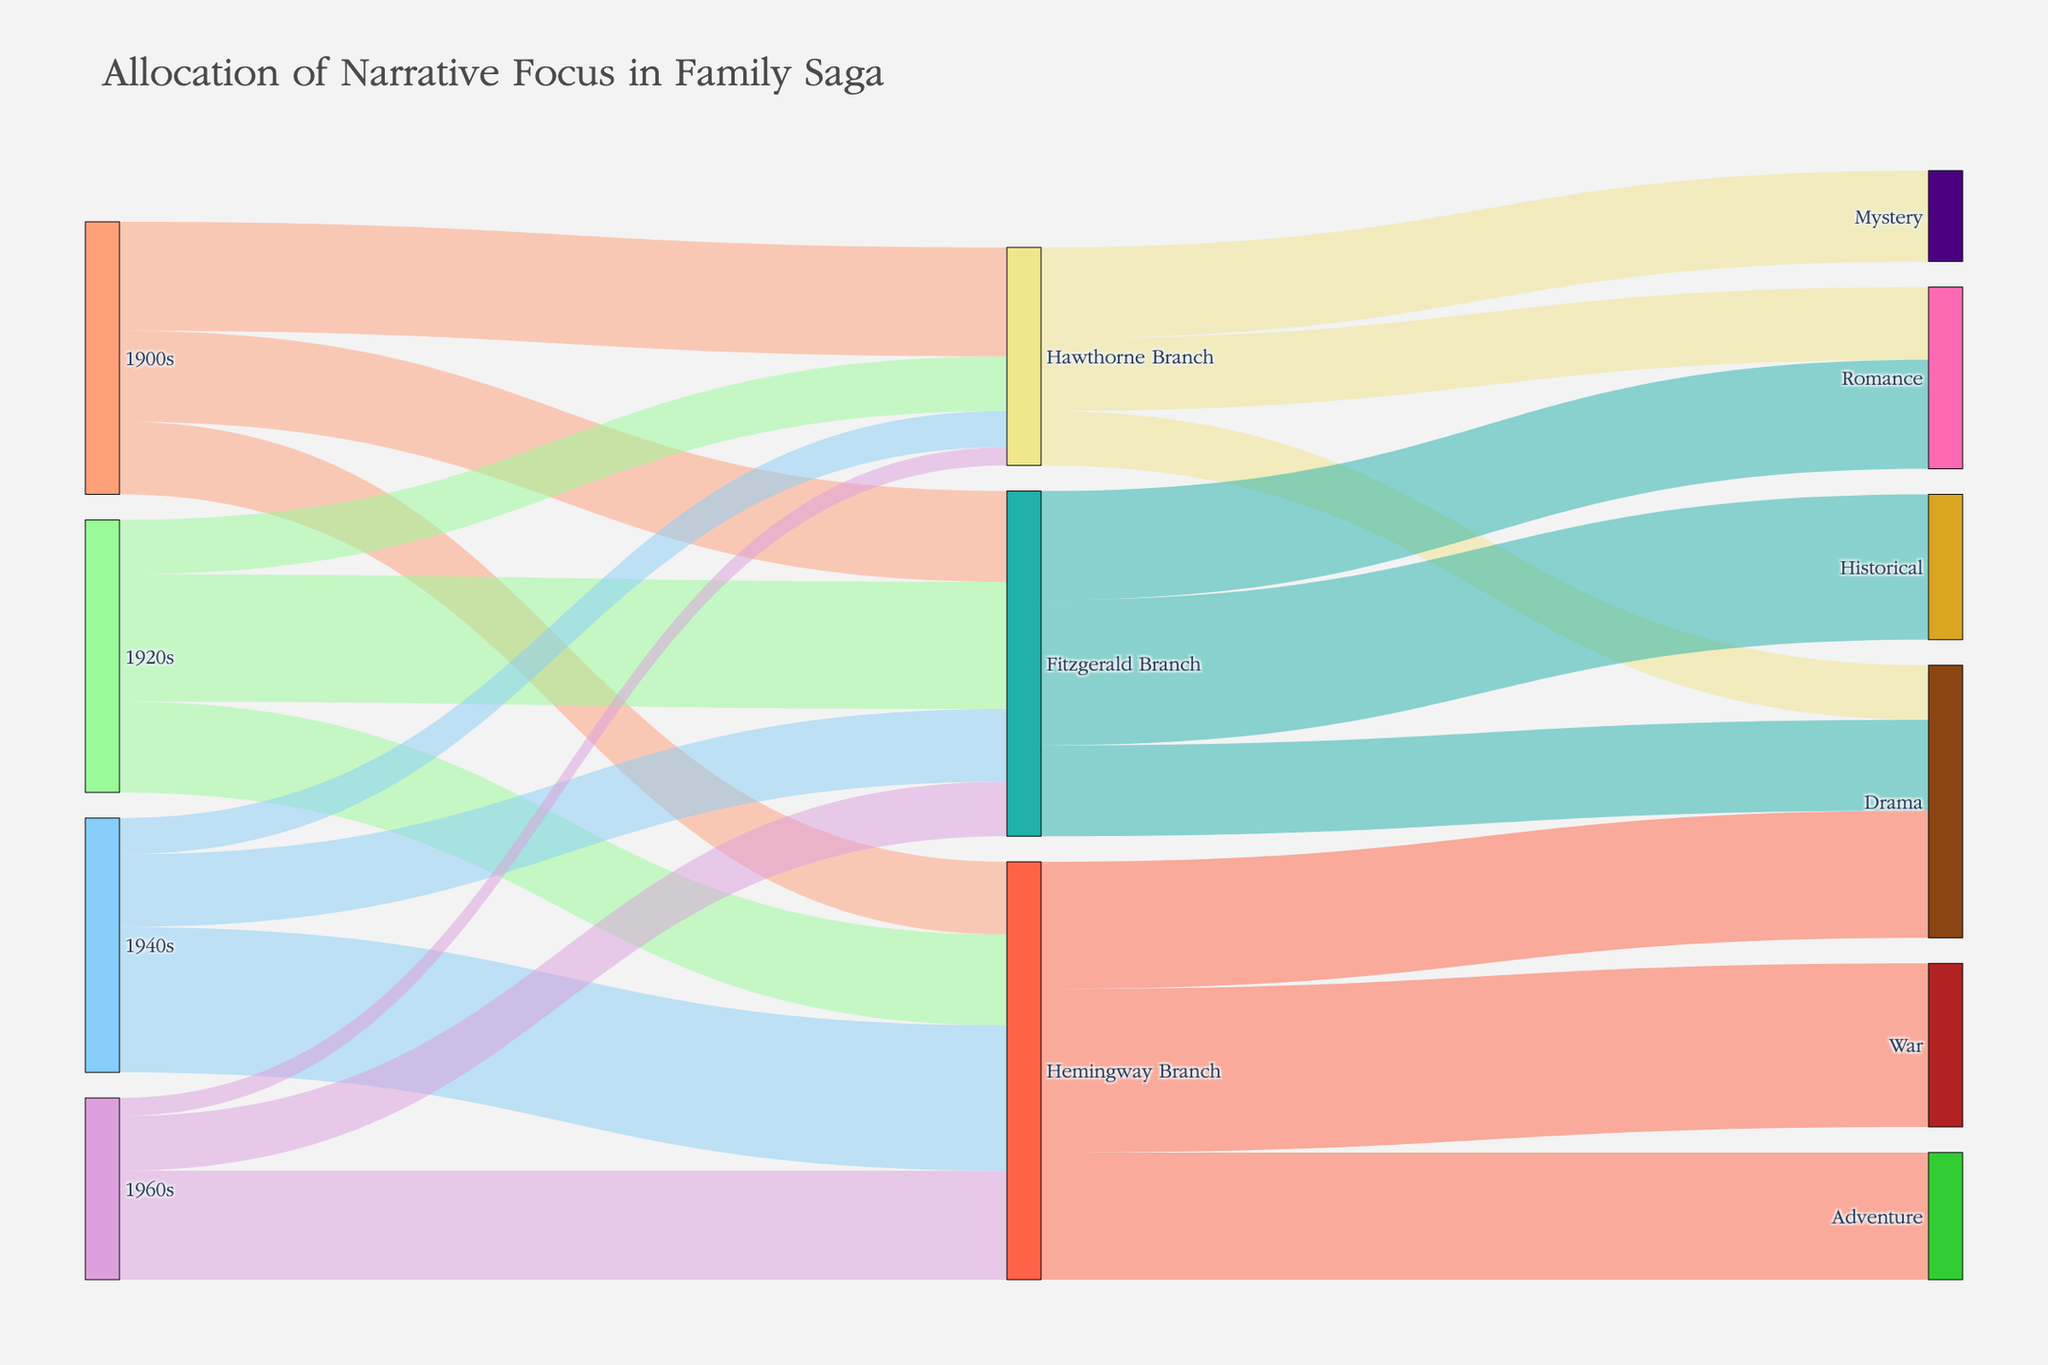Who has the most narrative focus in the 1960s? Look at the nodes connected to the "1960s" source; the "Hemingway Branch" has the largest value of 30, which is the highest among the branches from the 1960s.
Answer: Hemingway Branch Which family branch has the greatest narrative focus in the Romance genre? The branches leading to "Romance" should be considered. The "Fitzgerald Branch" with a value of 30 has the highest narrative focus in Romance.
Answer: Fitzgerald Branch What is the combined narrative focus of the "Hawthorne Branch" across all time periods? Add the values connecting from time periods to the "Hawthorne Branch": 30 (1900s) + 15 (1920s) + 10 (1940s) + 5 (1960s) = 60.
Answer: 60 Compare the narrative focus of "Adventure" and "Historical" genres. Which one has more focus? Look at the values of "Adventure" (35 from Hemingway) and "Historical" (40 from Fitzgerald). The "Historical" genre has a higher value.
Answer: Historical What is the total narrative focus on the "Drama" genre? Sum the narrative focuses: 15 (Hawthorne) + 25 (Fitzgerald) + 35 (Hemingway) = 75.
Answer: 75 What are the distinct time periods featured in the diagram? Identify the unique "source" nodes that are time periods: "1900s", "1920s", "1940s", "1960s".
Answer: 1900s, 1920s, 1940s, 1960s Which decade shows the highest combined narrative focus, and what is its value? Add the values for each decade: 1900s (75), 1920s (75), 1940s (70), and 1960s (50). The 1900s and 1920s both have the highest combined narrative focus of 75.
Answer: 1900s, 1920s, 75 What proportion of the Fitzgerald Branch's narrative focus in the 1940s is in the "War" genre? The Fitzgerald Branch has a value of 20 in the 1940s, and there is no direct link to "War" for Fitzgerald Branch. The proportion is therefore 0.
Answer: 0 